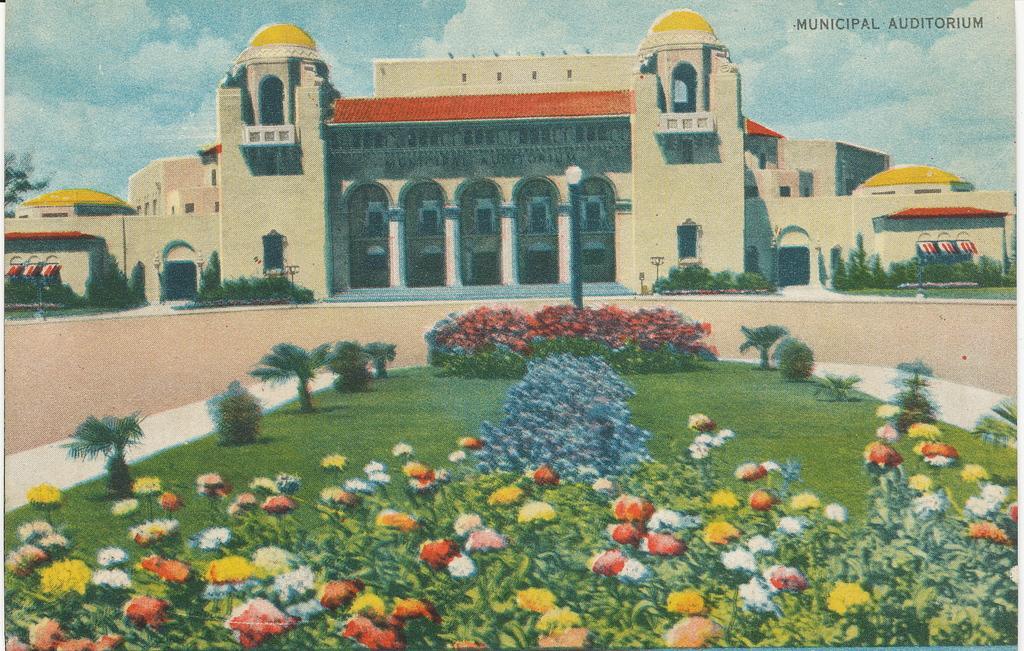Please provide a concise description of this image. In this picture there is a poster. In the centre of the poster I can see the buildings. At the bottom I can see the flowers on the plants, beside that I can see the grass. At the top I can see the sky and clouds. In the top right corner there is a watermark. 